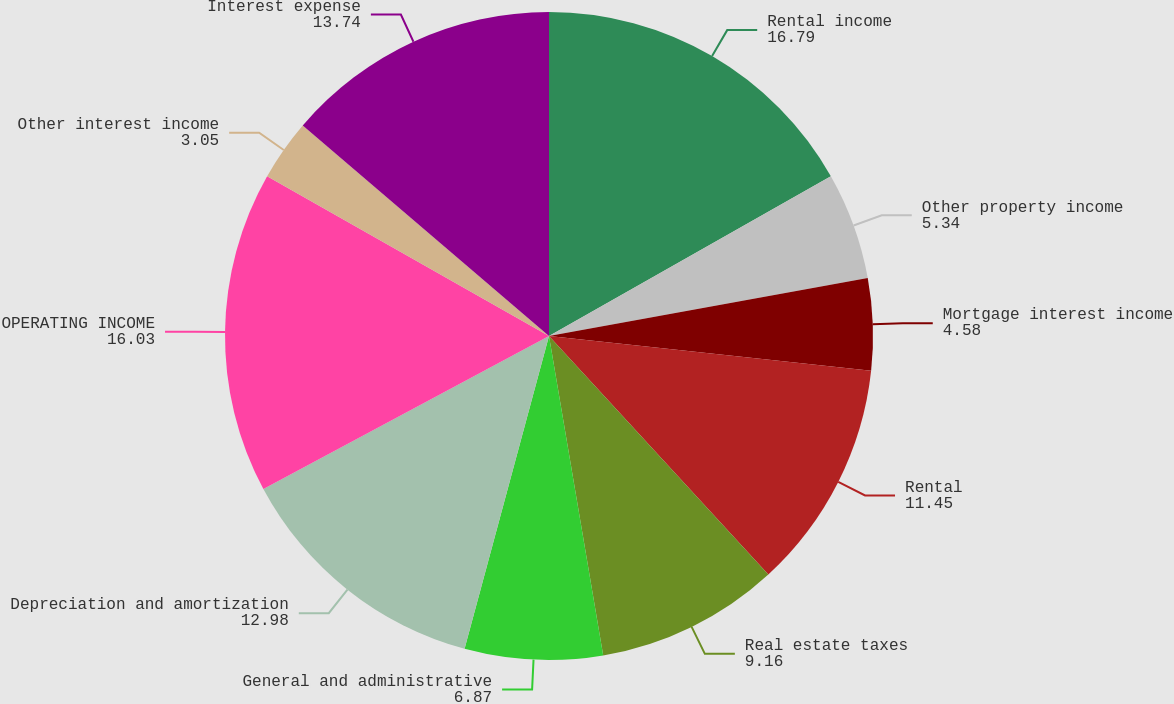Convert chart to OTSL. <chart><loc_0><loc_0><loc_500><loc_500><pie_chart><fcel>Rental income<fcel>Other property income<fcel>Mortgage interest income<fcel>Rental<fcel>Real estate taxes<fcel>General and administrative<fcel>Depreciation and amortization<fcel>OPERATING INCOME<fcel>Other interest income<fcel>Interest expense<nl><fcel>16.79%<fcel>5.34%<fcel>4.58%<fcel>11.45%<fcel>9.16%<fcel>6.87%<fcel>12.98%<fcel>16.03%<fcel>3.05%<fcel>13.74%<nl></chart> 